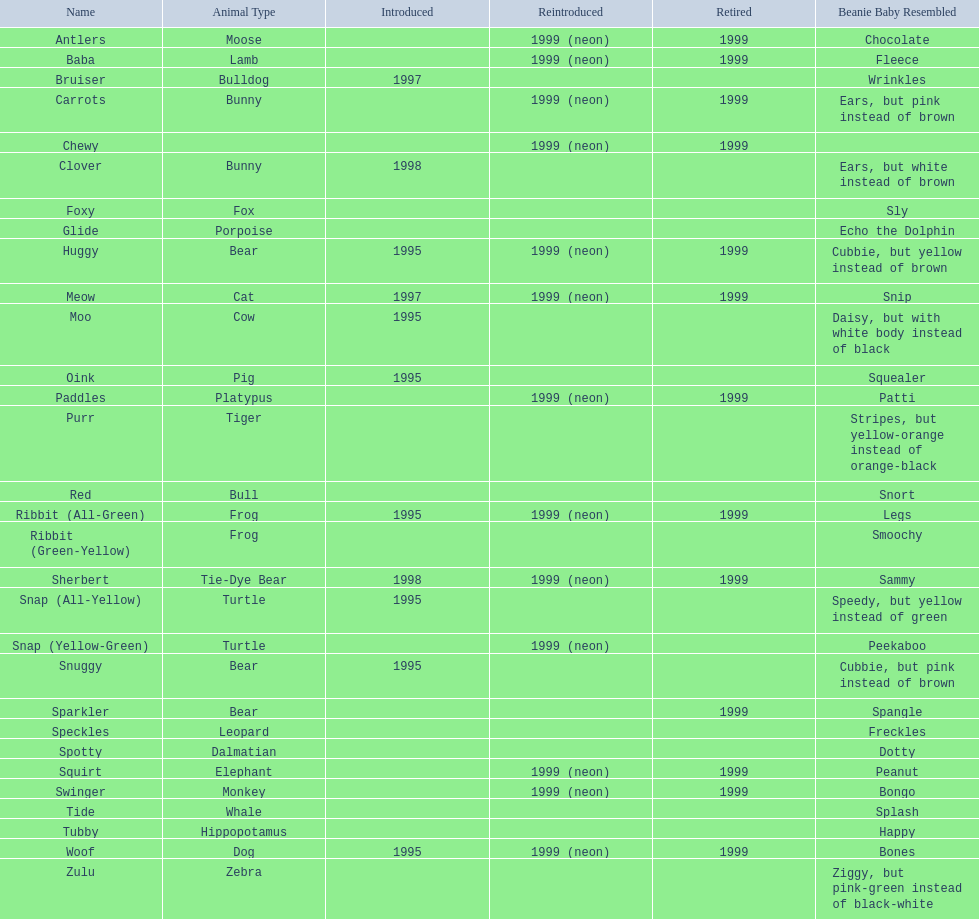What species are pillow friends? Moose, Lamb, Bulldog, Bunny, Bunny, Fox, Porpoise, Bear, Cat, Cow, Pig, Platypus, Tiger, Bull, Frog, Frog, Tie-Dye Bear, Turtle, Turtle, Bear, Bear, Leopard, Dalmatian, Elephant, Monkey, Whale, Hippopotamus, Dog, Zebra. What is the name of the dalmatian? Spotty. 